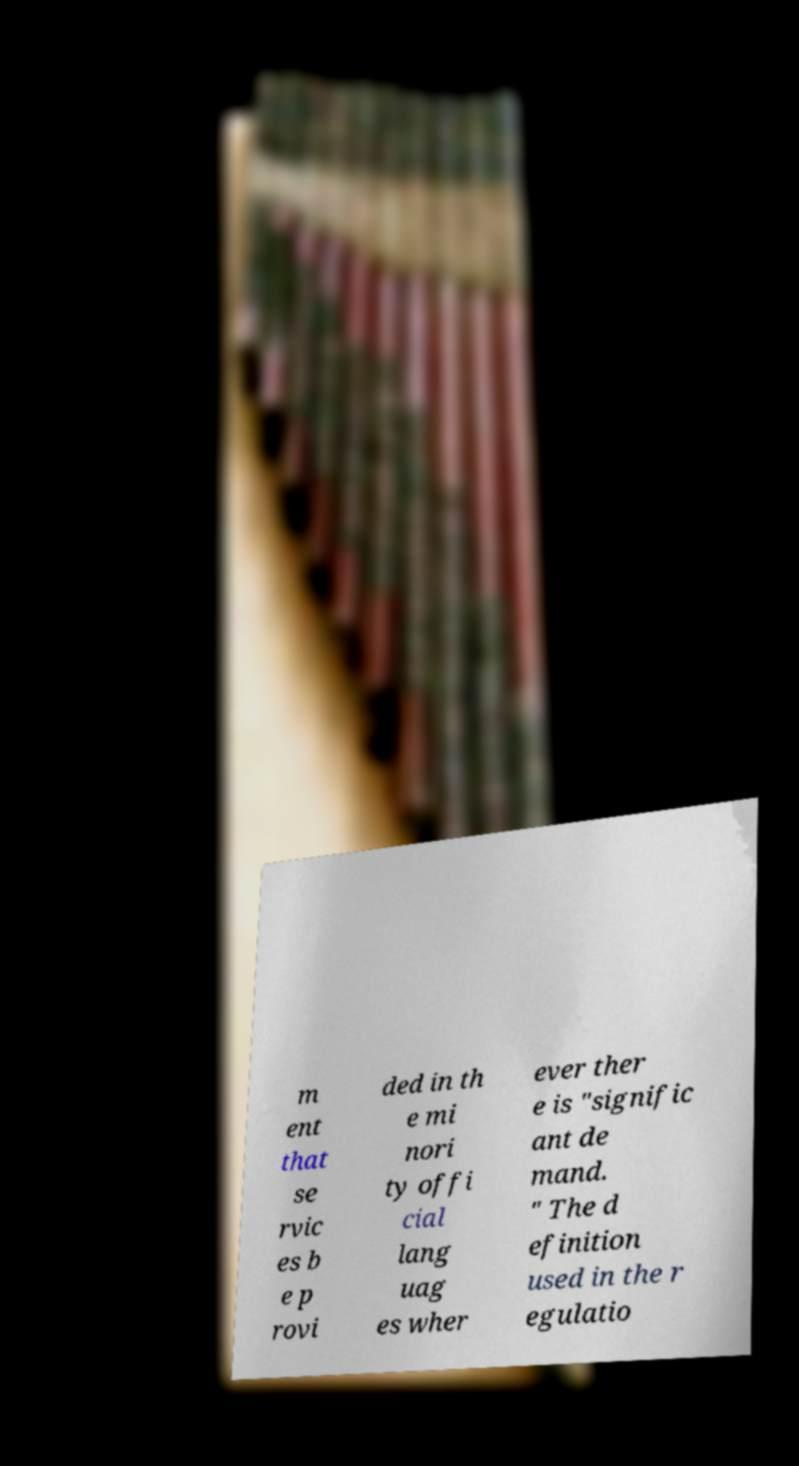Can you read and provide the text displayed in the image?This photo seems to have some interesting text. Can you extract and type it out for me? m ent that se rvic es b e p rovi ded in th e mi nori ty offi cial lang uag es wher ever ther e is "signific ant de mand. " The d efinition used in the r egulatio 